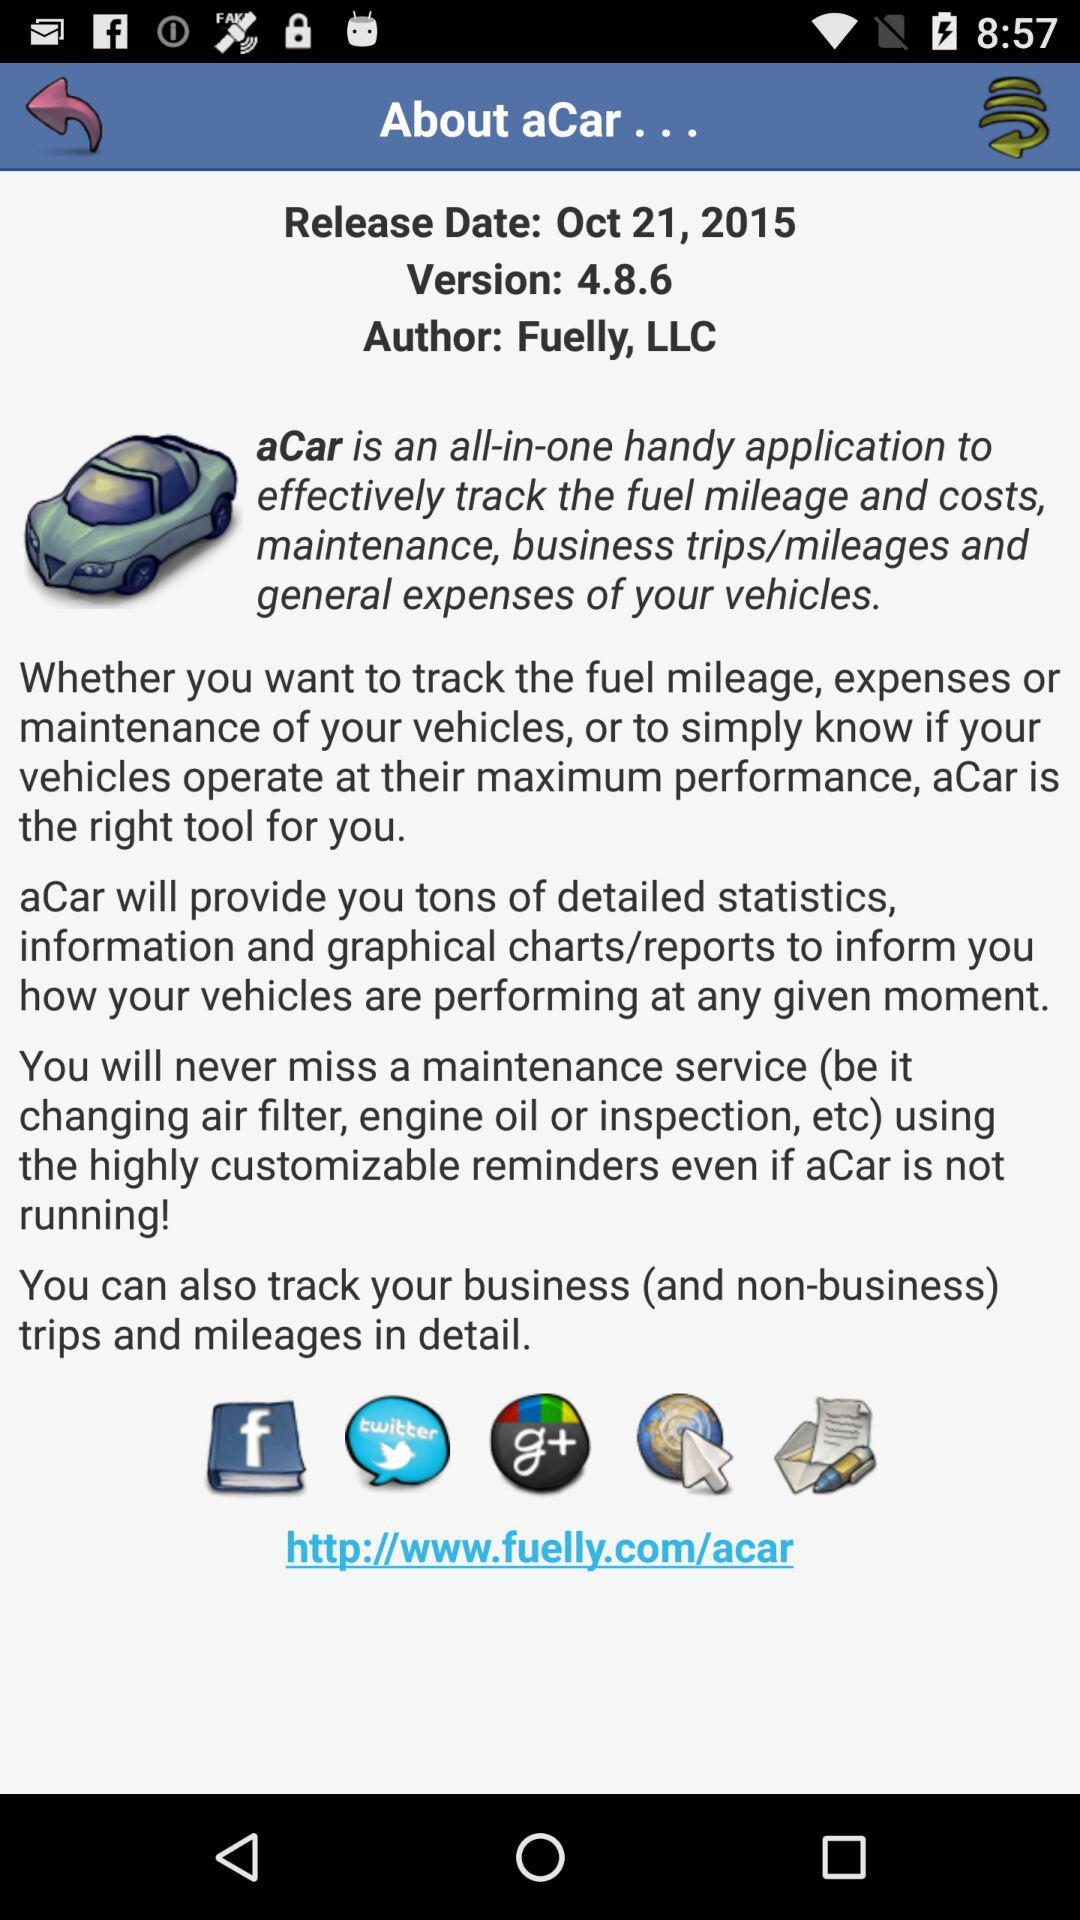What is the release date? The release date is October 21, 2015. 